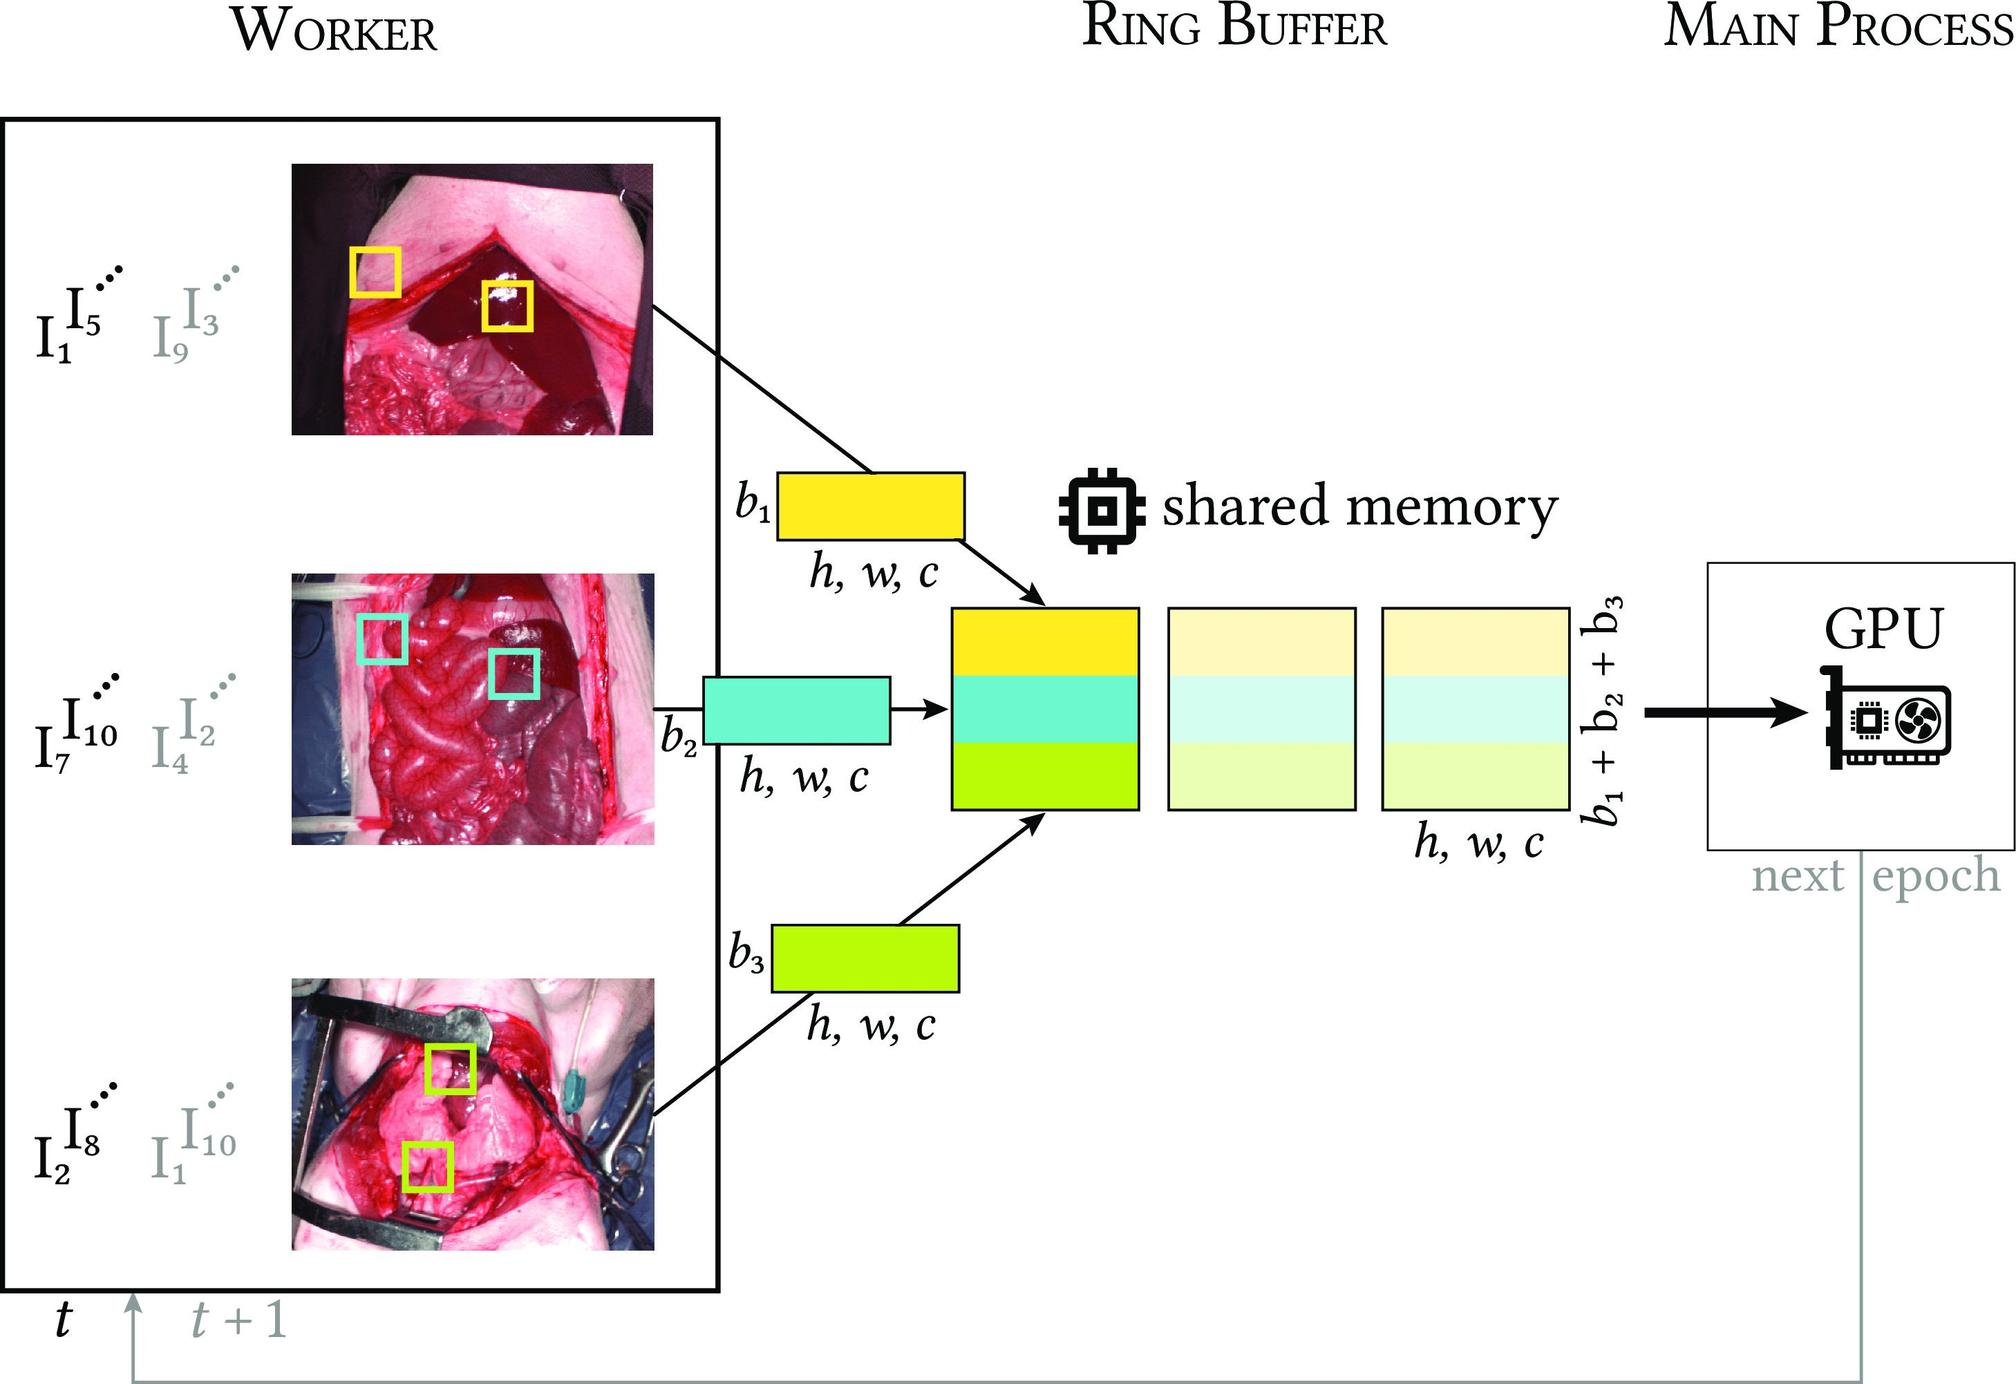What does the 't' at the bottom of the figure represent? A. The threshold level for data processing. B. The type of tasks to be processed. C. The time sequence of images being processed. D. The temperature at which the processing is optimal. The 't' with an arrow pointing to 't + 1' suggests a timeline or sequence. Given the context of the diagram with images and processing steps, it is reasonable to interpret 't' as representing the time at which the images are being processed, indicating a sequence over time. Therefore, the correct answer is C. 